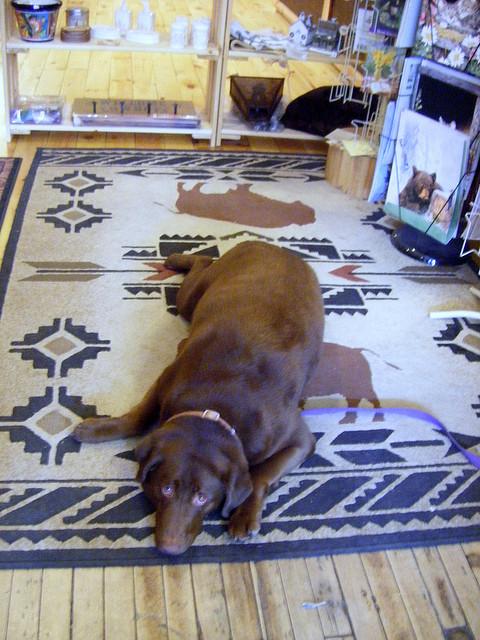What is around the dog's neck?
Give a very brief answer. Collar. What kind of animal is on the carpet?
Short answer required. Dog. What animal is printed on the carpet?
Answer briefly. Buffalo. 